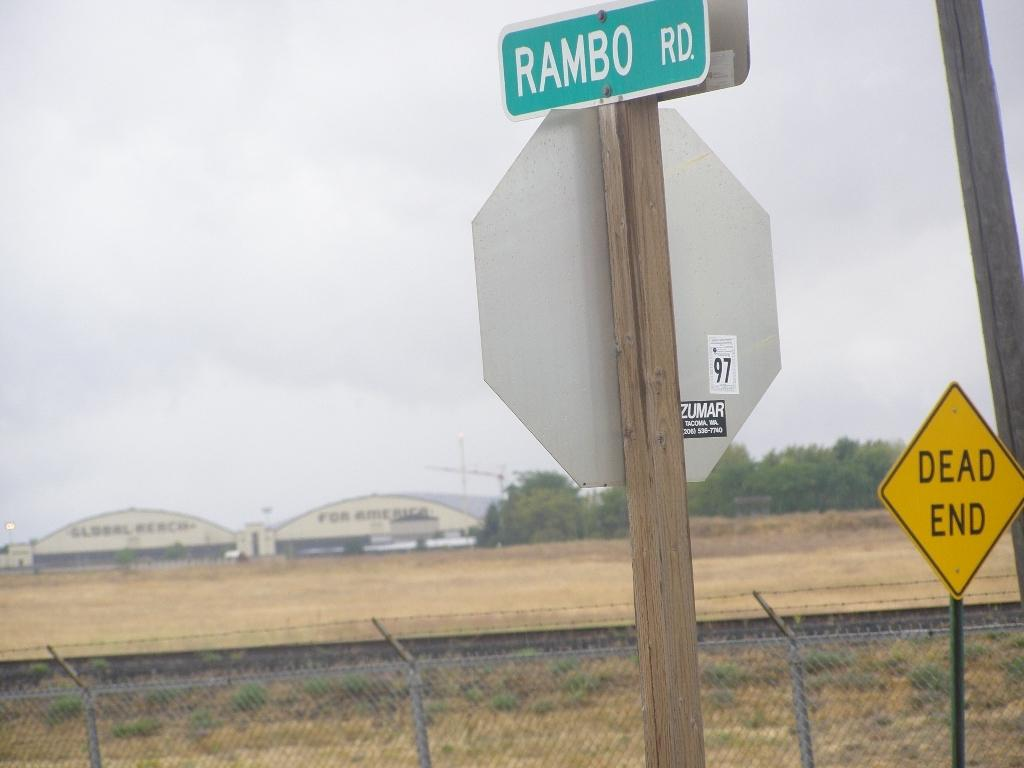<image>
Create a compact narrative representing the image presented. Near the road there are a couple of signs, one which indicates the street is Rambo Rd 